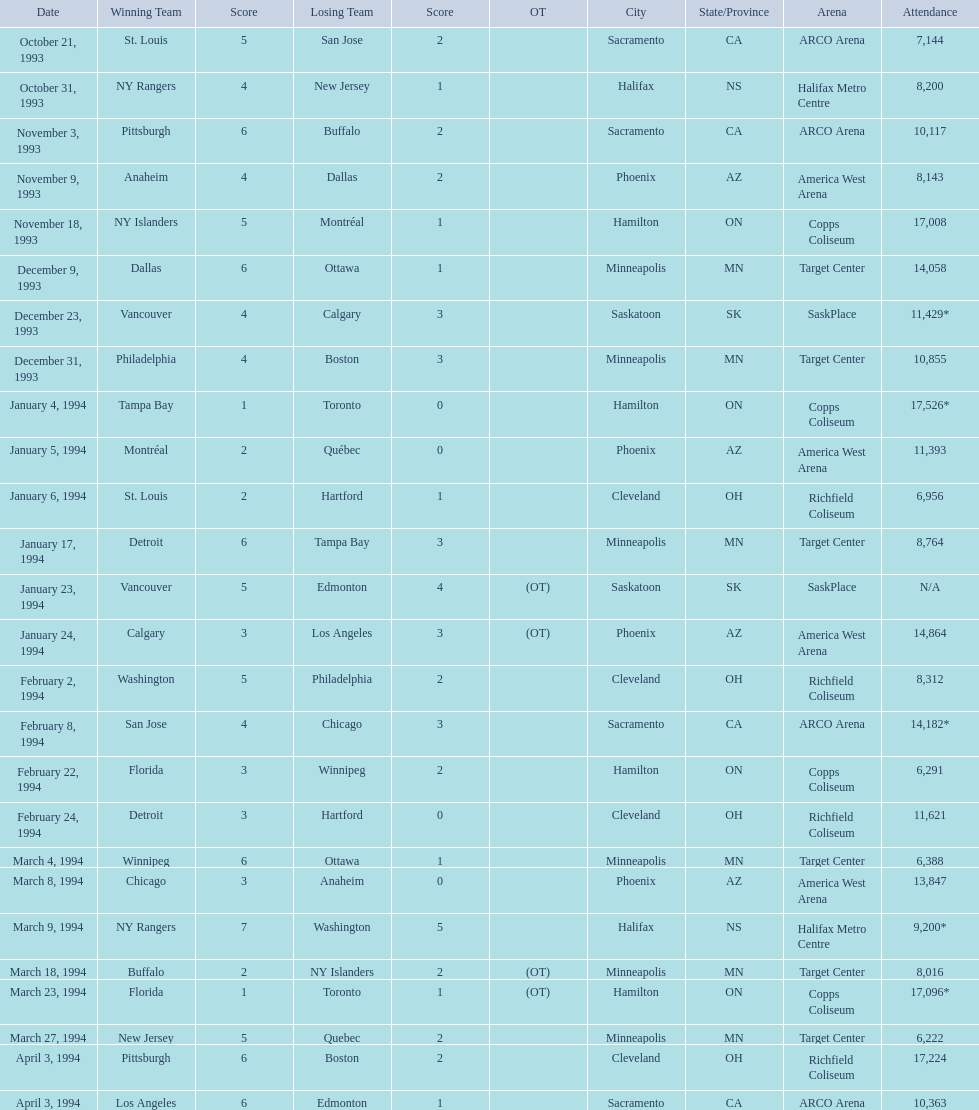What dates featured a winning team with only one point? January 4, 1994, March 23, 1994. Between these two instances, which one had a higher number of attendees? January 4, 1994. 